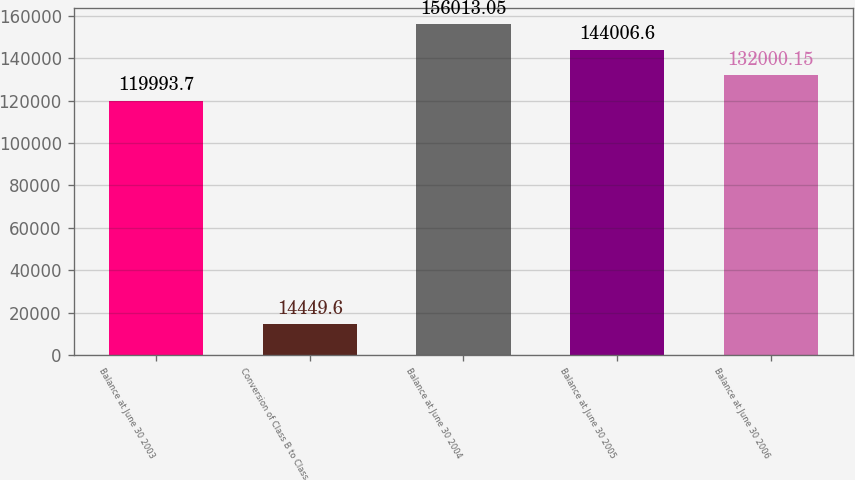Convert chart to OTSL. <chart><loc_0><loc_0><loc_500><loc_500><bar_chart><fcel>Balance at June 30 2003<fcel>Conversion of Class B to Class<fcel>Balance at June 30 2004<fcel>Balance at June 30 2005<fcel>Balance at June 30 2006<nl><fcel>119994<fcel>14449.6<fcel>156013<fcel>144007<fcel>132000<nl></chart> 